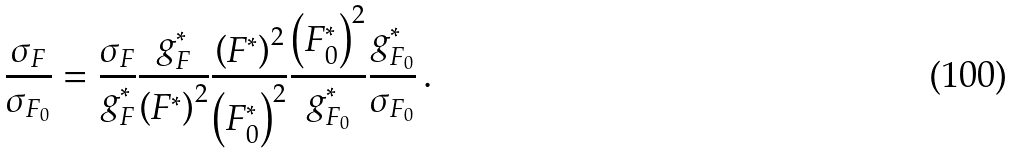Convert formula to latex. <formula><loc_0><loc_0><loc_500><loc_500>\frac { \sigma _ { F } } { \sigma _ { F _ { 0 } } } = \frac { \sigma _ { F } } { g _ { F } ^ { \ast } } \frac { g _ { F } ^ { \ast } } { \left ( F ^ { \ast } \right ) ^ { 2 } } \frac { \left ( F ^ { \ast } \right ) ^ { 2 } } { \left ( F _ { 0 } ^ { \ast } \right ) ^ { 2 } } \frac { \left ( F _ { 0 } ^ { \ast } \right ) ^ { 2 } } { g _ { F _ { 0 } } ^ { \ast } } \frac { g _ { F _ { 0 } } ^ { \ast } } { \sigma _ { F _ { 0 } } } \, .</formula> 